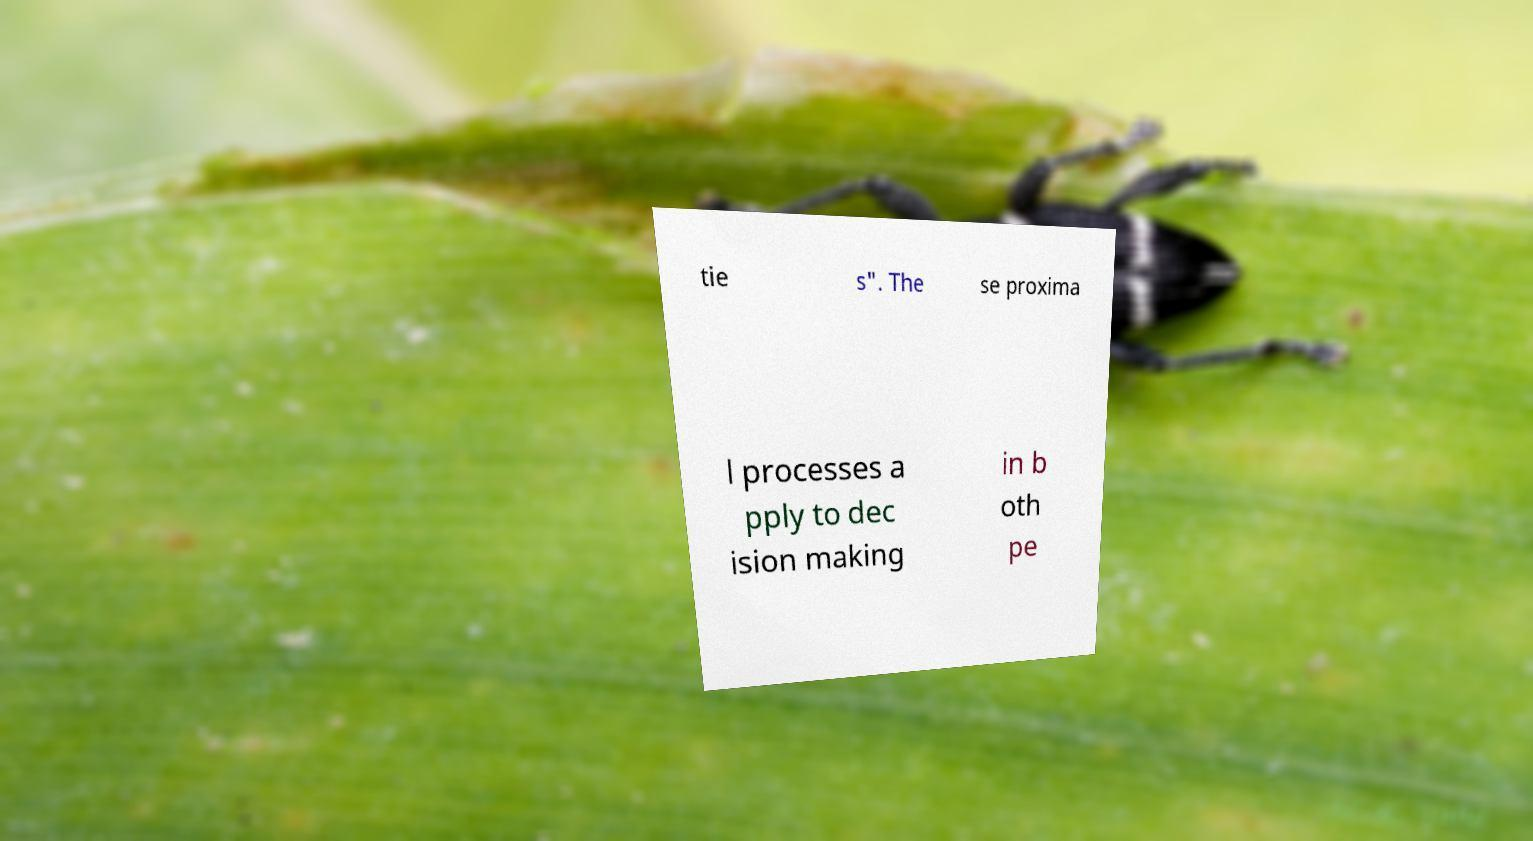Can you read and provide the text displayed in the image?This photo seems to have some interesting text. Can you extract and type it out for me? tie s". The se proxima l processes a pply to dec ision making in b oth pe 